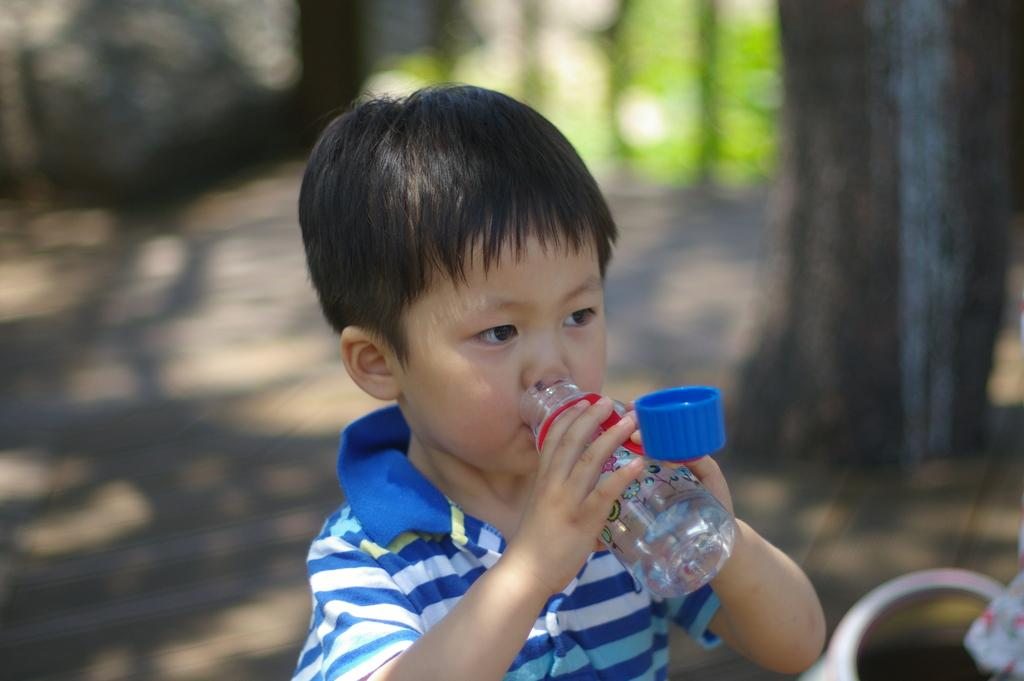What can be observed about the background of the image? The background of the image is blurry. What type of natural elements can be seen in the image? There are trees visible in the image. Who is the main subject in the image? There is a boy in the image. What is the boy holding in his hands? The boy is holding a bottle in his hands. What is the boy doing with the bottle? The boy is drinking water from the bottle. What type of headwear is the boy wearing? The boy is wearing a cap. Can you see any goats in the image? No, there are no goats present in the image. Is the boy sailing a ship in the image? No, the boy is not sailing a ship in the image; he is drinking water from a bottle. 